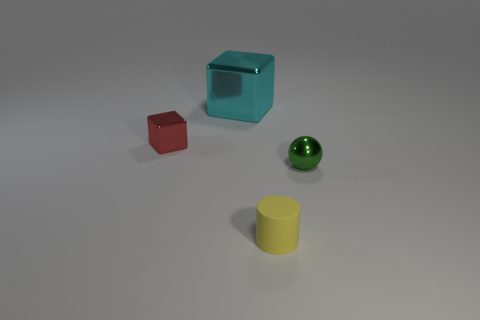Add 2 big blue matte spheres. How many objects exist? 6 Subtract all balls. How many objects are left? 3 Subtract all tiny yellow rubber objects. Subtract all yellow rubber cylinders. How many objects are left? 2 Add 2 small yellow cylinders. How many small yellow cylinders are left? 3 Add 1 tiny yellow things. How many tiny yellow things exist? 2 Subtract 0 red spheres. How many objects are left? 4 